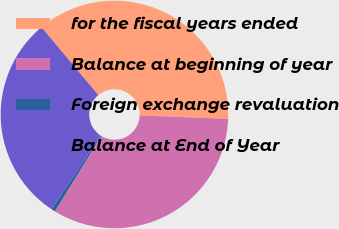<chart> <loc_0><loc_0><loc_500><loc_500><pie_chart><fcel>for the fiscal years ended<fcel>Balance at beginning of year<fcel>Foreign exchange revaluation<fcel>Balance at End of Year<nl><fcel>36.7%<fcel>33.16%<fcel>0.53%<fcel>29.62%<nl></chart> 